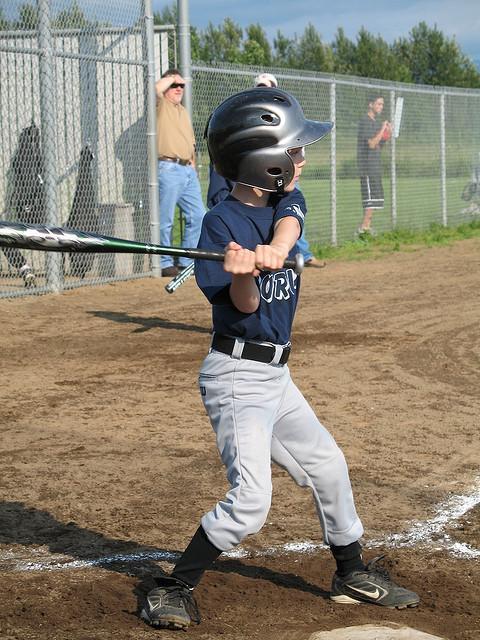How many people can be seen?
Give a very brief answer. 3. How many giraffes are shown?
Give a very brief answer. 0. 